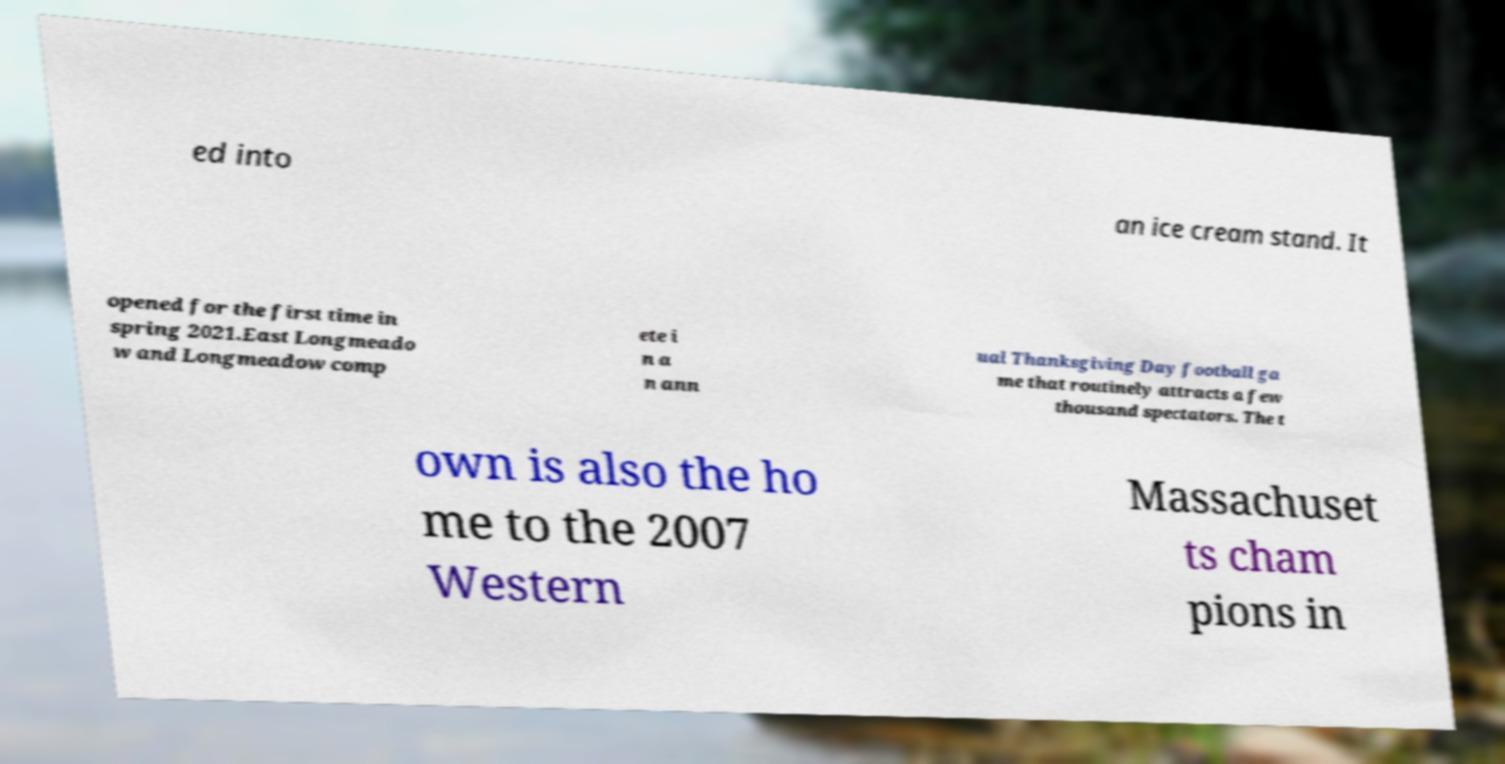What messages or text are displayed in this image? I need them in a readable, typed format. ed into an ice cream stand. It opened for the first time in spring 2021.East Longmeado w and Longmeadow comp ete i n a n ann ual Thanksgiving Day football ga me that routinely attracts a few thousand spectators. The t own is also the ho me to the 2007 Western Massachuset ts cham pions in 